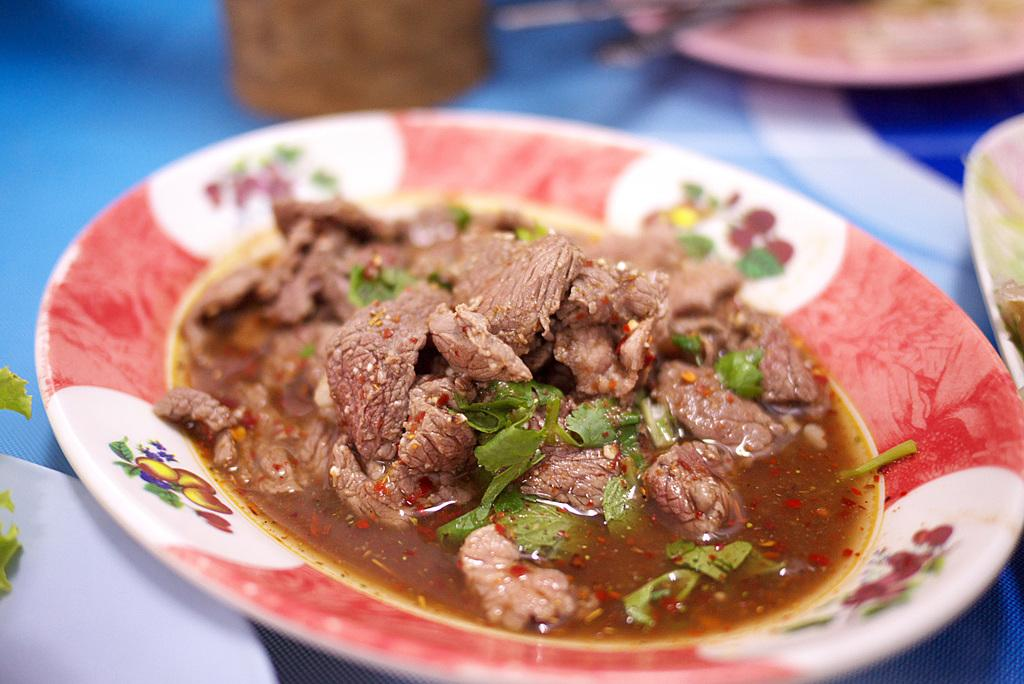What is the main subject of the image? The main subject of the image is a food item on a plate. Can you describe the surrounding context of the food item? There are additional plates on a surface in the image. What type of ring is being worn by the food item in the image? There is no ring present in the image, as the subject is a food item on a plate. 